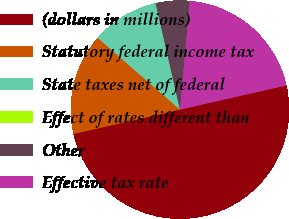<chart> <loc_0><loc_0><loc_500><loc_500><pie_chart><fcel>(dollars in millions)<fcel>Statutory federal income tax<fcel>State taxes net of federal<fcel>Effect of rates different than<fcel>Other<fcel>Effective tax rate<nl><fcel>49.98%<fcel>15.0%<fcel>10.0%<fcel>0.01%<fcel>5.01%<fcel>20.0%<nl></chart> 